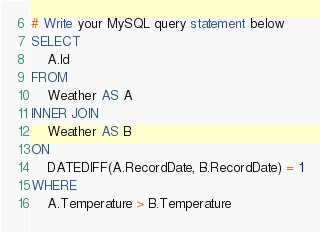<code> <loc_0><loc_0><loc_500><loc_500><_SQL_># Write your MySQL query statement below
SELECT
    A.Id
FROM
    Weather AS A
INNER JOIN
    Weather AS B
ON
    DATEDIFF(A.RecordDate, B.RecordDate) = 1
WHERE
    A.Temperature > B.Temperature</code> 